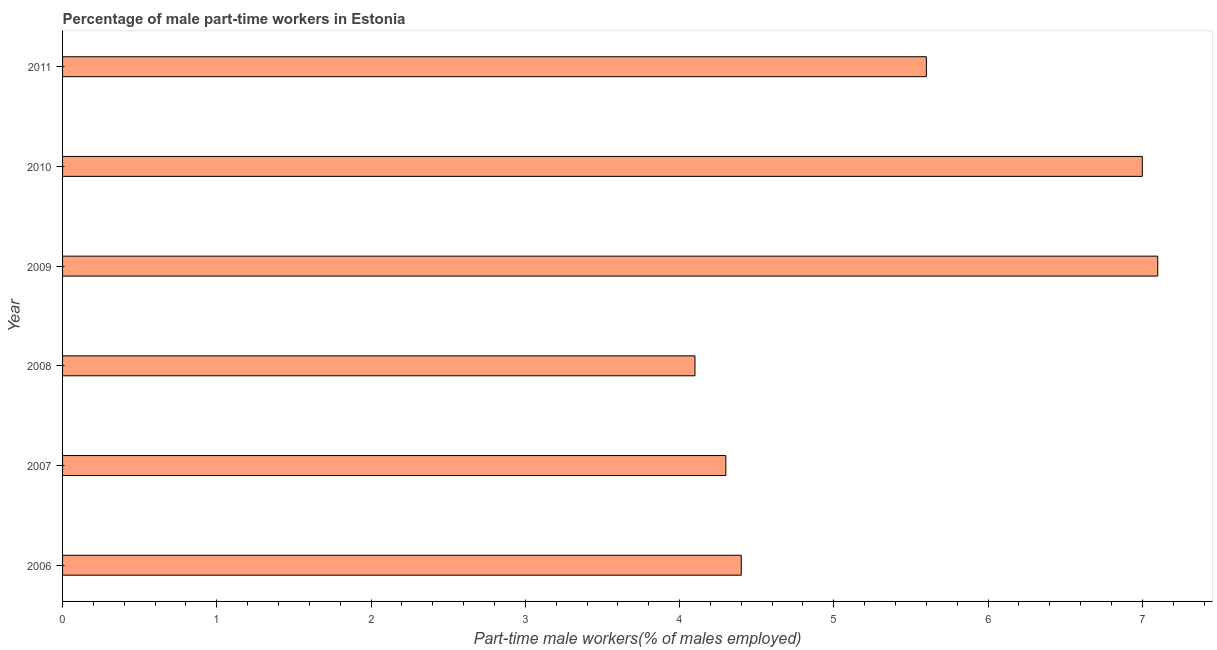What is the title of the graph?
Provide a short and direct response. Percentage of male part-time workers in Estonia. What is the label or title of the X-axis?
Ensure brevity in your answer.  Part-time male workers(% of males employed). What is the percentage of part-time male workers in 2011?
Keep it short and to the point. 5.6. Across all years, what is the maximum percentage of part-time male workers?
Your answer should be very brief. 7.1. Across all years, what is the minimum percentage of part-time male workers?
Provide a short and direct response. 4.1. What is the sum of the percentage of part-time male workers?
Ensure brevity in your answer.  32.5. What is the difference between the percentage of part-time male workers in 2008 and 2010?
Keep it short and to the point. -2.9. What is the average percentage of part-time male workers per year?
Your answer should be very brief. 5.42. In how many years, is the percentage of part-time male workers greater than 5 %?
Your answer should be compact. 3. What is the ratio of the percentage of part-time male workers in 2008 to that in 2011?
Give a very brief answer. 0.73. What is the difference between the highest and the second highest percentage of part-time male workers?
Your response must be concise. 0.1. Is the sum of the percentage of part-time male workers in 2007 and 2010 greater than the maximum percentage of part-time male workers across all years?
Your answer should be very brief. Yes. How many bars are there?
Provide a short and direct response. 6. How many years are there in the graph?
Your answer should be very brief. 6. Are the values on the major ticks of X-axis written in scientific E-notation?
Provide a short and direct response. No. What is the Part-time male workers(% of males employed) of 2006?
Make the answer very short. 4.4. What is the Part-time male workers(% of males employed) in 2007?
Your answer should be compact. 4.3. What is the Part-time male workers(% of males employed) in 2008?
Your response must be concise. 4.1. What is the Part-time male workers(% of males employed) of 2009?
Offer a very short reply. 7.1. What is the Part-time male workers(% of males employed) of 2010?
Your response must be concise. 7. What is the Part-time male workers(% of males employed) in 2011?
Offer a very short reply. 5.6. What is the difference between the Part-time male workers(% of males employed) in 2007 and 2008?
Provide a short and direct response. 0.2. What is the difference between the Part-time male workers(% of males employed) in 2007 and 2010?
Keep it short and to the point. -2.7. What is the difference between the Part-time male workers(% of males employed) in 2007 and 2011?
Provide a succinct answer. -1.3. What is the difference between the Part-time male workers(% of males employed) in 2008 and 2009?
Provide a short and direct response. -3. What is the difference between the Part-time male workers(% of males employed) in 2008 and 2010?
Ensure brevity in your answer.  -2.9. What is the difference between the Part-time male workers(% of males employed) in 2008 and 2011?
Give a very brief answer. -1.5. What is the difference between the Part-time male workers(% of males employed) in 2009 and 2010?
Offer a very short reply. 0.1. What is the difference between the Part-time male workers(% of males employed) in 2009 and 2011?
Your answer should be very brief. 1.5. What is the ratio of the Part-time male workers(% of males employed) in 2006 to that in 2007?
Keep it short and to the point. 1.02. What is the ratio of the Part-time male workers(% of males employed) in 2006 to that in 2008?
Provide a short and direct response. 1.07. What is the ratio of the Part-time male workers(% of males employed) in 2006 to that in 2009?
Your response must be concise. 0.62. What is the ratio of the Part-time male workers(% of males employed) in 2006 to that in 2010?
Your response must be concise. 0.63. What is the ratio of the Part-time male workers(% of males employed) in 2006 to that in 2011?
Provide a short and direct response. 0.79. What is the ratio of the Part-time male workers(% of males employed) in 2007 to that in 2008?
Make the answer very short. 1.05. What is the ratio of the Part-time male workers(% of males employed) in 2007 to that in 2009?
Provide a succinct answer. 0.61. What is the ratio of the Part-time male workers(% of males employed) in 2007 to that in 2010?
Your answer should be very brief. 0.61. What is the ratio of the Part-time male workers(% of males employed) in 2007 to that in 2011?
Make the answer very short. 0.77. What is the ratio of the Part-time male workers(% of males employed) in 2008 to that in 2009?
Your answer should be very brief. 0.58. What is the ratio of the Part-time male workers(% of males employed) in 2008 to that in 2010?
Your answer should be compact. 0.59. What is the ratio of the Part-time male workers(% of males employed) in 2008 to that in 2011?
Offer a terse response. 0.73. What is the ratio of the Part-time male workers(% of males employed) in 2009 to that in 2011?
Offer a terse response. 1.27. What is the ratio of the Part-time male workers(% of males employed) in 2010 to that in 2011?
Keep it short and to the point. 1.25. 